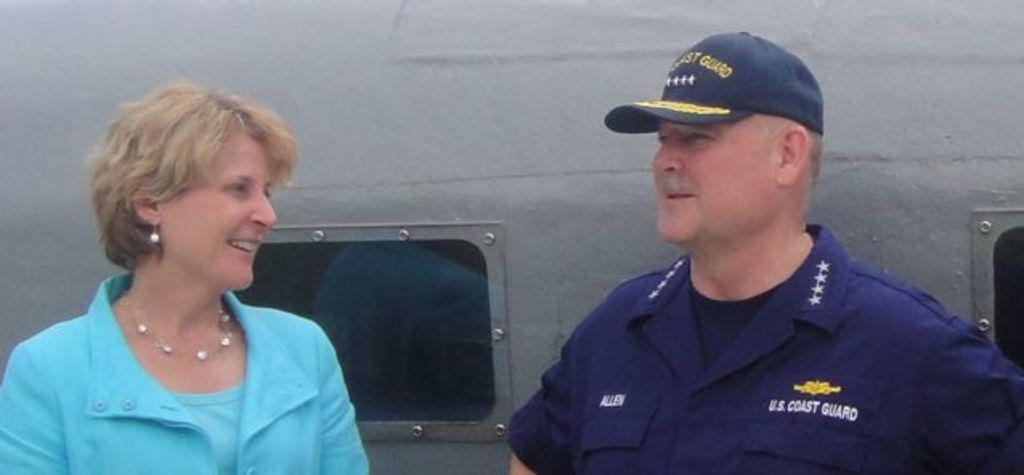<image>
Write a terse but informative summary of the picture. a man that is wearing a coast guard outfit 